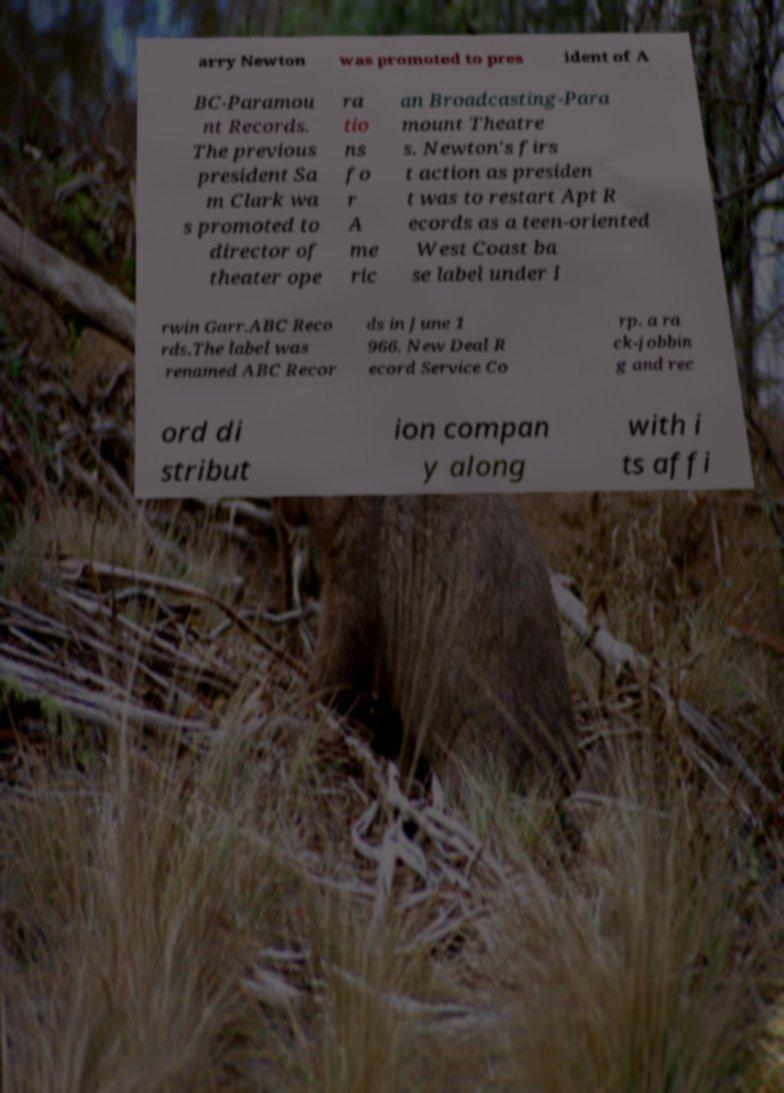Please read and relay the text visible in this image. What does it say? arry Newton was promoted to pres ident of A BC-Paramou nt Records. The previous president Sa m Clark wa s promoted to director of theater ope ra tio ns fo r A me ric an Broadcasting-Para mount Theatre s. Newton's firs t action as presiden t was to restart Apt R ecords as a teen-oriented West Coast ba se label under I rwin Garr.ABC Reco rds.The label was renamed ABC Recor ds in June 1 966. New Deal R ecord Service Co rp. a ra ck-jobbin g and rec ord di stribut ion compan y along with i ts affi 